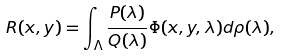<formula> <loc_0><loc_0><loc_500><loc_500>R ( x , y ) = \int _ { \Lambda } \frac { P ( \lambda ) } { Q ( \lambda ) } \Phi ( x , y , \lambda ) d \rho ( \lambda ) ,</formula> 